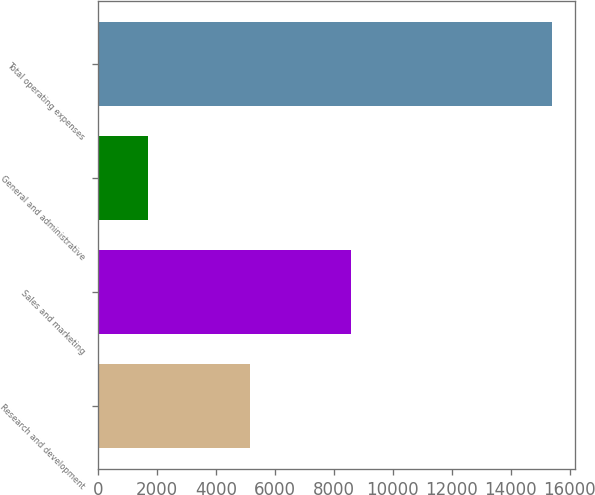Convert chart to OTSL. <chart><loc_0><loc_0><loc_500><loc_500><bar_chart><fcel>Research and development<fcel>Sales and marketing<fcel>General and administrative<fcel>Total operating expenses<nl><fcel>5160<fcel>8574<fcel>1680<fcel>15414<nl></chart> 